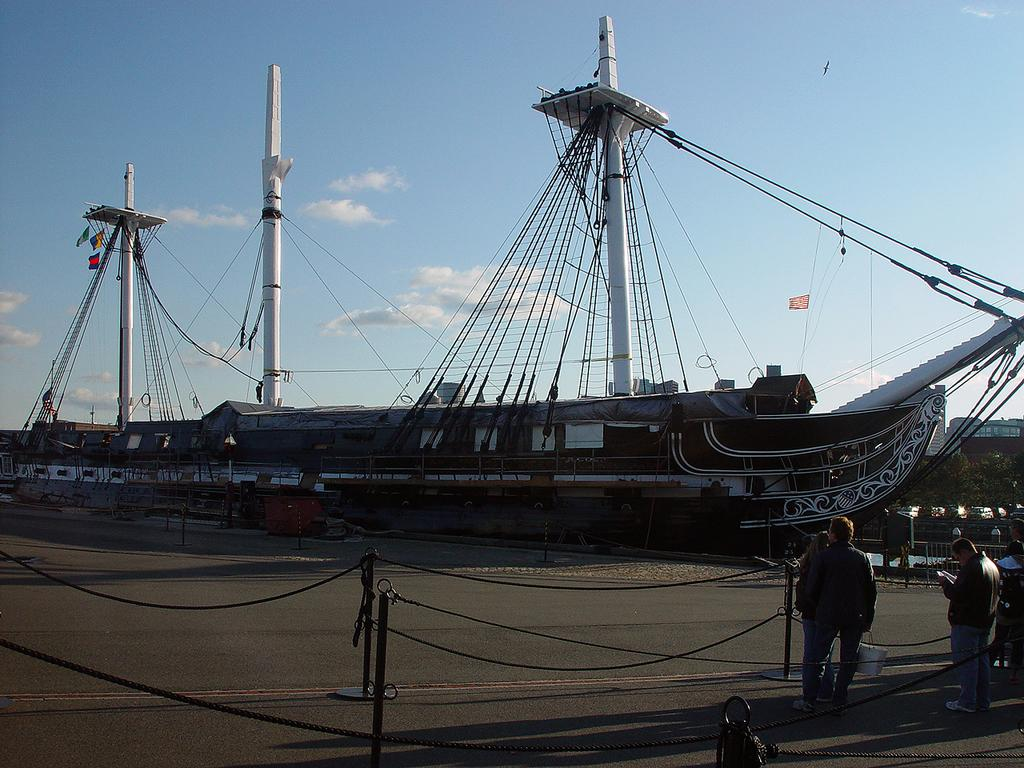How many people are in the image? There are three persons standing in the image. What objects can be seen in the image besides the people? There are poles in the image. What can be seen in the background of the image? There is a ship in the background of the image. What is the color of the sky in the image? The sky is blue and white in color. What type of cracker is being used to soothe the person's throat in the image? There is no cracker or person with a sore throat present in the image. How many coils are visible in the image? There are no coils visible in the image. 